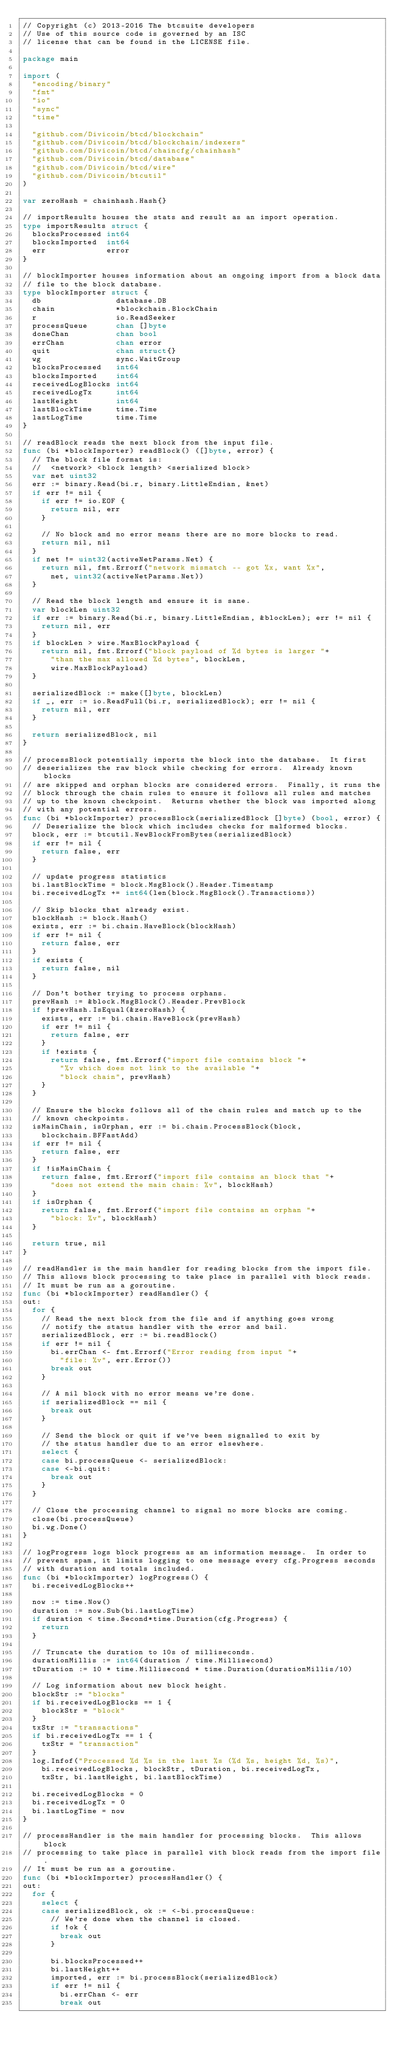<code> <loc_0><loc_0><loc_500><loc_500><_Go_>// Copyright (c) 2013-2016 The btcsuite developers
// Use of this source code is governed by an ISC
// license that can be found in the LICENSE file.

package main

import (
	"encoding/binary"
	"fmt"
	"io"
	"sync"
	"time"

	"github.com/Divicoin/btcd/blockchain"
	"github.com/Divicoin/btcd/blockchain/indexers"
	"github.com/Divicoin/btcd/chaincfg/chainhash"
	"github.com/Divicoin/btcd/database"
	"github.com/Divicoin/btcd/wire"
	"github.com/Divicoin/btcutil"
)

var zeroHash = chainhash.Hash{}

// importResults houses the stats and result as an import operation.
type importResults struct {
	blocksProcessed int64
	blocksImported  int64
	err             error
}

// blockImporter houses information about an ongoing import from a block data
// file to the block database.
type blockImporter struct {
	db                database.DB
	chain             *blockchain.BlockChain
	r                 io.ReadSeeker
	processQueue      chan []byte
	doneChan          chan bool
	errChan           chan error
	quit              chan struct{}
	wg                sync.WaitGroup
	blocksProcessed   int64
	blocksImported    int64
	receivedLogBlocks int64
	receivedLogTx     int64
	lastHeight        int64
	lastBlockTime     time.Time
	lastLogTime       time.Time
}

// readBlock reads the next block from the input file.
func (bi *blockImporter) readBlock() ([]byte, error) {
	// The block file format is:
	//  <network> <block length> <serialized block>
	var net uint32
	err := binary.Read(bi.r, binary.LittleEndian, &net)
	if err != nil {
		if err != io.EOF {
			return nil, err
		}

		// No block and no error means there are no more blocks to read.
		return nil, nil
	}
	if net != uint32(activeNetParams.Net) {
		return nil, fmt.Errorf("network mismatch -- got %x, want %x",
			net, uint32(activeNetParams.Net))
	}

	// Read the block length and ensure it is sane.
	var blockLen uint32
	if err := binary.Read(bi.r, binary.LittleEndian, &blockLen); err != nil {
		return nil, err
	}
	if blockLen > wire.MaxBlockPayload {
		return nil, fmt.Errorf("block payload of %d bytes is larger "+
			"than the max allowed %d bytes", blockLen,
			wire.MaxBlockPayload)
	}

	serializedBlock := make([]byte, blockLen)
	if _, err := io.ReadFull(bi.r, serializedBlock); err != nil {
		return nil, err
	}

	return serializedBlock, nil
}

// processBlock potentially imports the block into the database.  It first
// deserializes the raw block while checking for errors.  Already known blocks
// are skipped and orphan blocks are considered errors.  Finally, it runs the
// block through the chain rules to ensure it follows all rules and matches
// up to the known checkpoint.  Returns whether the block was imported along
// with any potential errors.
func (bi *blockImporter) processBlock(serializedBlock []byte) (bool, error) {
	// Deserialize the block which includes checks for malformed blocks.
	block, err := btcutil.NewBlockFromBytes(serializedBlock)
	if err != nil {
		return false, err
	}

	// update progress statistics
	bi.lastBlockTime = block.MsgBlock().Header.Timestamp
	bi.receivedLogTx += int64(len(block.MsgBlock().Transactions))

	// Skip blocks that already exist.
	blockHash := block.Hash()
	exists, err := bi.chain.HaveBlock(blockHash)
	if err != nil {
		return false, err
	}
	if exists {
		return false, nil
	}

	// Don't bother trying to process orphans.
	prevHash := &block.MsgBlock().Header.PrevBlock
	if !prevHash.IsEqual(&zeroHash) {
		exists, err := bi.chain.HaveBlock(prevHash)
		if err != nil {
			return false, err
		}
		if !exists {
			return false, fmt.Errorf("import file contains block "+
				"%v which does not link to the available "+
				"block chain", prevHash)
		}
	}

	// Ensure the blocks follows all of the chain rules and match up to the
	// known checkpoints.
	isMainChain, isOrphan, err := bi.chain.ProcessBlock(block,
		blockchain.BFFastAdd)
	if err != nil {
		return false, err
	}
	if !isMainChain {
		return false, fmt.Errorf("import file contains an block that "+
			"does not extend the main chain: %v", blockHash)
	}
	if isOrphan {
		return false, fmt.Errorf("import file contains an orphan "+
			"block: %v", blockHash)
	}

	return true, nil
}

// readHandler is the main handler for reading blocks from the import file.
// This allows block processing to take place in parallel with block reads.
// It must be run as a goroutine.
func (bi *blockImporter) readHandler() {
out:
	for {
		// Read the next block from the file and if anything goes wrong
		// notify the status handler with the error and bail.
		serializedBlock, err := bi.readBlock()
		if err != nil {
			bi.errChan <- fmt.Errorf("Error reading from input "+
				"file: %v", err.Error())
			break out
		}

		// A nil block with no error means we're done.
		if serializedBlock == nil {
			break out
		}

		// Send the block or quit if we've been signalled to exit by
		// the status handler due to an error elsewhere.
		select {
		case bi.processQueue <- serializedBlock:
		case <-bi.quit:
			break out
		}
	}

	// Close the processing channel to signal no more blocks are coming.
	close(bi.processQueue)
	bi.wg.Done()
}

// logProgress logs block progress as an information message.  In order to
// prevent spam, it limits logging to one message every cfg.Progress seconds
// with duration and totals included.
func (bi *blockImporter) logProgress() {
	bi.receivedLogBlocks++

	now := time.Now()
	duration := now.Sub(bi.lastLogTime)
	if duration < time.Second*time.Duration(cfg.Progress) {
		return
	}

	// Truncate the duration to 10s of milliseconds.
	durationMillis := int64(duration / time.Millisecond)
	tDuration := 10 * time.Millisecond * time.Duration(durationMillis/10)

	// Log information about new block height.
	blockStr := "blocks"
	if bi.receivedLogBlocks == 1 {
		blockStr = "block"
	}
	txStr := "transactions"
	if bi.receivedLogTx == 1 {
		txStr = "transaction"
	}
	log.Infof("Processed %d %s in the last %s (%d %s, height %d, %s)",
		bi.receivedLogBlocks, blockStr, tDuration, bi.receivedLogTx,
		txStr, bi.lastHeight, bi.lastBlockTime)

	bi.receivedLogBlocks = 0
	bi.receivedLogTx = 0
	bi.lastLogTime = now
}

// processHandler is the main handler for processing blocks.  This allows block
// processing to take place in parallel with block reads from the import file.
// It must be run as a goroutine.
func (bi *blockImporter) processHandler() {
out:
	for {
		select {
		case serializedBlock, ok := <-bi.processQueue:
			// We're done when the channel is closed.
			if !ok {
				break out
			}

			bi.blocksProcessed++
			bi.lastHeight++
			imported, err := bi.processBlock(serializedBlock)
			if err != nil {
				bi.errChan <- err
				break out</code> 